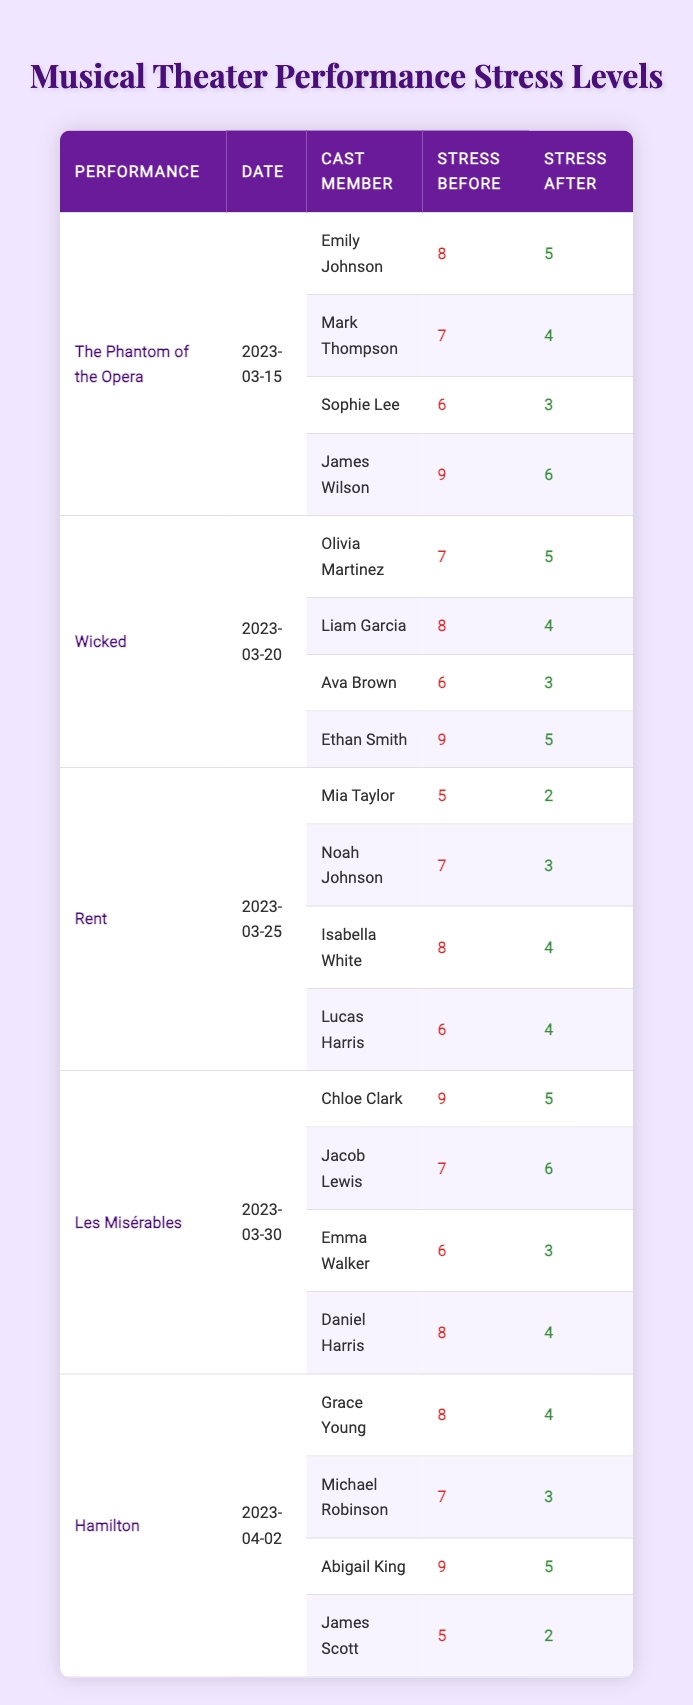What was Emily Johnson's stress level before her performance in "The Phantom of the Opera"? According to the table, Emily Johnson's stress level before the performance was listed as 8.
Answer: 8 What was the difference in stress levels for Mark Thompson before and after his performance in "The Phantom of the Opera"? Mark Thompson had a stress level of 7 before and 4 after his performance. The difference is 7 - 4 = 3.
Answer: 3 Which performance had the highest average stress level before the shows? The stress levels before the performances are: The Phantom of the Opera (8+7+6+9=30), Wicked (7+8+6+9=30), Rent (5+7+8+6=26), Les Misérables (9+7+6+8=30), and Hamilton (8+7+9+5=29). The average for The Phantom of the Opera, Wicked, and Les Misérables is 30/4 = 7.5. They are the highest.
Answer: The Phantom of the Opera, Wicked, and Les Misérables What is the total stress level of cast members after the performance of "Wicked"? The stress levels after the performance are: 5 (Olivia) + 4 (Liam) + 3 (Ava) + 5 (Ethan) = 17.
Answer: 17 Did any cast member have a higher stress level after their performance compared to their stress level before? For Ethan Smith, his stress level after (5) is lower than before (9) but higher compared to others. No one had a higher level after.
Answer: No Who had the lowest stress level after their performance in "Rent"? Lucas Harris had a stress level of 4 after, which is lower than Mia (2), Noah (3), and Isabella (4). Thus Mia Taylor had the lowest stress level with 2.
Answer: Mia Taylor What was the total decrease in stress levels among all cast members after "Hamilton"? The reductions are: Grace (4), Michael (4), Abigail (4), and James (3), totaling: 8 + 4 + 5 + 3 = 20.
Answer: 20 Out of the performances listed, which one had the highest single drop in stress level for any cast member? Looking at the change per cast member: Mia Taylor dropped from 5 to 2 (3), but Abigail King dropped from 9 to 5 (4), which is the highest drop established.
Answer: Hamilton (Abigail King, 4) What is the average stress level after performances for all cast members across all performances? Summing stress levels after: 5 + 4 + 3 + 6 + 5 + 4 + 3 + 4 + 2 + 3 + 4 + 5 + 5 + 4 + 3 = 56; there are 16 cast members, so 56/16 = 3.5.
Answer: 3.5 